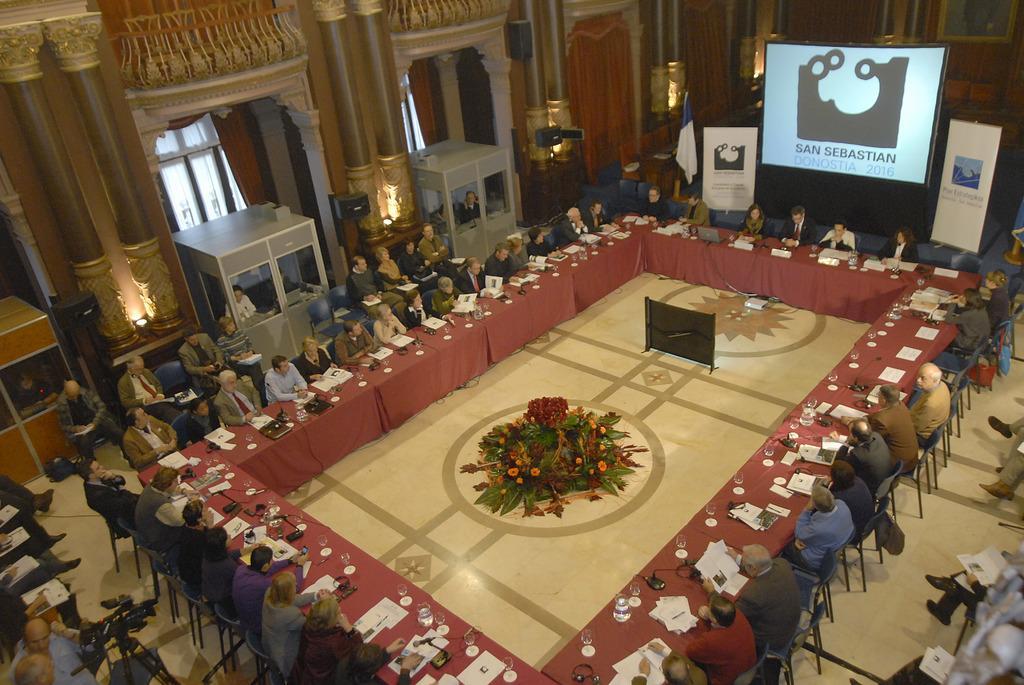Please provide a concise description of this image. In this image I see number of people in which all of them are sitting on chairs and there are number of tables on which there are number of things and I see the floor and I see the screen over here on which there is something written and I see 2 boards over here and I see the wall, pillars and I see the window over here. 